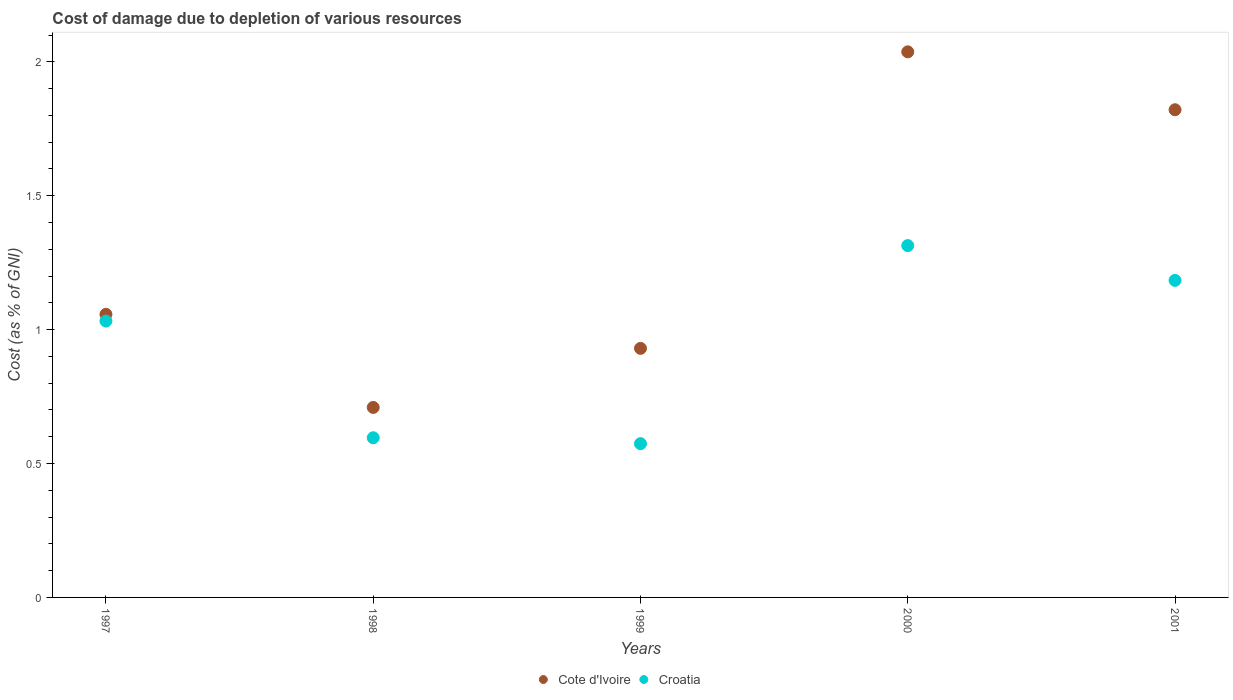Is the number of dotlines equal to the number of legend labels?
Your response must be concise. Yes. What is the cost of damage caused due to the depletion of various resources in Croatia in 2001?
Your answer should be compact. 1.18. Across all years, what is the maximum cost of damage caused due to the depletion of various resources in Croatia?
Your answer should be compact. 1.31. Across all years, what is the minimum cost of damage caused due to the depletion of various resources in Cote d'Ivoire?
Your response must be concise. 0.71. In which year was the cost of damage caused due to the depletion of various resources in Cote d'Ivoire maximum?
Provide a succinct answer. 2000. What is the total cost of damage caused due to the depletion of various resources in Croatia in the graph?
Provide a succinct answer. 4.7. What is the difference between the cost of damage caused due to the depletion of various resources in Cote d'Ivoire in 1999 and that in 2000?
Ensure brevity in your answer.  -1.11. What is the difference between the cost of damage caused due to the depletion of various resources in Cote d'Ivoire in 1998 and the cost of damage caused due to the depletion of various resources in Croatia in 1999?
Give a very brief answer. 0.14. What is the average cost of damage caused due to the depletion of various resources in Cote d'Ivoire per year?
Your answer should be compact. 1.31. In the year 2000, what is the difference between the cost of damage caused due to the depletion of various resources in Cote d'Ivoire and cost of damage caused due to the depletion of various resources in Croatia?
Offer a very short reply. 0.72. In how many years, is the cost of damage caused due to the depletion of various resources in Croatia greater than 1.4 %?
Offer a very short reply. 0. What is the ratio of the cost of damage caused due to the depletion of various resources in Croatia in 1997 to that in 2001?
Your response must be concise. 0.87. What is the difference between the highest and the second highest cost of damage caused due to the depletion of various resources in Cote d'Ivoire?
Your response must be concise. 0.22. What is the difference between the highest and the lowest cost of damage caused due to the depletion of various resources in Croatia?
Ensure brevity in your answer.  0.74. In how many years, is the cost of damage caused due to the depletion of various resources in Croatia greater than the average cost of damage caused due to the depletion of various resources in Croatia taken over all years?
Ensure brevity in your answer.  3. Is the cost of damage caused due to the depletion of various resources in Croatia strictly greater than the cost of damage caused due to the depletion of various resources in Cote d'Ivoire over the years?
Ensure brevity in your answer.  No. Is the cost of damage caused due to the depletion of various resources in Cote d'Ivoire strictly less than the cost of damage caused due to the depletion of various resources in Croatia over the years?
Make the answer very short. No. Does the graph contain any zero values?
Provide a short and direct response. No. How many legend labels are there?
Your response must be concise. 2. What is the title of the graph?
Keep it short and to the point. Cost of damage due to depletion of various resources. What is the label or title of the Y-axis?
Provide a succinct answer. Cost (as % of GNI). What is the Cost (as % of GNI) in Cote d'Ivoire in 1997?
Your response must be concise. 1.06. What is the Cost (as % of GNI) in Croatia in 1997?
Keep it short and to the point. 1.03. What is the Cost (as % of GNI) in Cote d'Ivoire in 1998?
Give a very brief answer. 0.71. What is the Cost (as % of GNI) in Croatia in 1998?
Give a very brief answer. 0.6. What is the Cost (as % of GNI) of Cote d'Ivoire in 1999?
Give a very brief answer. 0.93. What is the Cost (as % of GNI) in Croatia in 1999?
Provide a short and direct response. 0.57. What is the Cost (as % of GNI) of Cote d'Ivoire in 2000?
Make the answer very short. 2.04. What is the Cost (as % of GNI) of Croatia in 2000?
Your answer should be very brief. 1.31. What is the Cost (as % of GNI) of Cote d'Ivoire in 2001?
Provide a short and direct response. 1.82. What is the Cost (as % of GNI) of Croatia in 2001?
Give a very brief answer. 1.18. Across all years, what is the maximum Cost (as % of GNI) of Cote d'Ivoire?
Make the answer very short. 2.04. Across all years, what is the maximum Cost (as % of GNI) of Croatia?
Your answer should be compact. 1.31. Across all years, what is the minimum Cost (as % of GNI) in Cote d'Ivoire?
Provide a short and direct response. 0.71. Across all years, what is the minimum Cost (as % of GNI) of Croatia?
Keep it short and to the point. 0.57. What is the total Cost (as % of GNI) in Cote d'Ivoire in the graph?
Provide a short and direct response. 6.56. What is the total Cost (as % of GNI) in Croatia in the graph?
Your response must be concise. 4.7. What is the difference between the Cost (as % of GNI) in Cote d'Ivoire in 1997 and that in 1998?
Offer a very short reply. 0.35. What is the difference between the Cost (as % of GNI) of Croatia in 1997 and that in 1998?
Provide a succinct answer. 0.44. What is the difference between the Cost (as % of GNI) of Cote d'Ivoire in 1997 and that in 1999?
Your answer should be compact. 0.13. What is the difference between the Cost (as % of GNI) of Croatia in 1997 and that in 1999?
Your answer should be very brief. 0.46. What is the difference between the Cost (as % of GNI) of Cote d'Ivoire in 1997 and that in 2000?
Give a very brief answer. -0.98. What is the difference between the Cost (as % of GNI) of Croatia in 1997 and that in 2000?
Provide a short and direct response. -0.28. What is the difference between the Cost (as % of GNI) in Cote d'Ivoire in 1997 and that in 2001?
Offer a very short reply. -0.76. What is the difference between the Cost (as % of GNI) of Croatia in 1997 and that in 2001?
Keep it short and to the point. -0.15. What is the difference between the Cost (as % of GNI) in Cote d'Ivoire in 1998 and that in 1999?
Your answer should be very brief. -0.22. What is the difference between the Cost (as % of GNI) of Croatia in 1998 and that in 1999?
Give a very brief answer. 0.02. What is the difference between the Cost (as % of GNI) of Cote d'Ivoire in 1998 and that in 2000?
Offer a very short reply. -1.33. What is the difference between the Cost (as % of GNI) in Croatia in 1998 and that in 2000?
Give a very brief answer. -0.72. What is the difference between the Cost (as % of GNI) of Cote d'Ivoire in 1998 and that in 2001?
Give a very brief answer. -1.11. What is the difference between the Cost (as % of GNI) in Croatia in 1998 and that in 2001?
Provide a succinct answer. -0.59. What is the difference between the Cost (as % of GNI) of Cote d'Ivoire in 1999 and that in 2000?
Make the answer very short. -1.11. What is the difference between the Cost (as % of GNI) in Croatia in 1999 and that in 2000?
Provide a succinct answer. -0.74. What is the difference between the Cost (as % of GNI) of Cote d'Ivoire in 1999 and that in 2001?
Your response must be concise. -0.89. What is the difference between the Cost (as % of GNI) in Croatia in 1999 and that in 2001?
Offer a terse response. -0.61. What is the difference between the Cost (as % of GNI) in Cote d'Ivoire in 2000 and that in 2001?
Your answer should be compact. 0.22. What is the difference between the Cost (as % of GNI) of Croatia in 2000 and that in 2001?
Ensure brevity in your answer.  0.13. What is the difference between the Cost (as % of GNI) in Cote d'Ivoire in 1997 and the Cost (as % of GNI) in Croatia in 1998?
Ensure brevity in your answer.  0.46. What is the difference between the Cost (as % of GNI) in Cote d'Ivoire in 1997 and the Cost (as % of GNI) in Croatia in 1999?
Keep it short and to the point. 0.48. What is the difference between the Cost (as % of GNI) of Cote d'Ivoire in 1997 and the Cost (as % of GNI) of Croatia in 2000?
Ensure brevity in your answer.  -0.26. What is the difference between the Cost (as % of GNI) in Cote d'Ivoire in 1997 and the Cost (as % of GNI) in Croatia in 2001?
Your answer should be compact. -0.13. What is the difference between the Cost (as % of GNI) of Cote d'Ivoire in 1998 and the Cost (as % of GNI) of Croatia in 1999?
Make the answer very short. 0.14. What is the difference between the Cost (as % of GNI) of Cote d'Ivoire in 1998 and the Cost (as % of GNI) of Croatia in 2000?
Your answer should be compact. -0.6. What is the difference between the Cost (as % of GNI) of Cote d'Ivoire in 1998 and the Cost (as % of GNI) of Croatia in 2001?
Provide a succinct answer. -0.47. What is the difference between the Cost (as % of GNI) in Cote d'Ivoire in 1999 and the Cost (as % of GNI) in Croatia in 2000?
Make the answer very short. -0.38. What is the difference between the Cost (as % of GNI) of Cote d'Ivoire in 1999 and the Cost (as % of GNI) of Croatia in 2001?
Ensure brevity in your answer.  -0.25. What is the difference between the Cost (as % of GNI) of Cote d'Ivoire in 2000 and the Cost (as % of GNI) of Croatia in 2001?
Your answer should be compact. 0.85. What is the average Cost (as % of GNI) of Cote d'Ivoire per year?
Give a very brief answer. 1.31. What is the average Cost (as % of GNI) in Croatia per year?
Your answer should be compact. 0.94. In the year 1997, what is the difference between the Cost (as % of GNI) of Cote d'Ivoire and Cost (as % of GNI) of Croatia?
Your answer should be very brief. 0.03. In the year 1998, what is the difference between the Cost (as % of GNI) of Cote d'Ivoire and Cost (as % of GNI) of Croatia?
Provide a short and direct response. 0.11. In the year 1999, what is the difference between the Cost (as % of GNI) in Cote d'Ivoire and Cost (as % of GNI) in Croatia?
Provide a short and direct response. 0.36. In the year 2000, what is the difference between the Cost (as % of GNI) in Cote d'Ivoire and Cost (as % of GNI) in Croatia?
Ensure brevity in your answer.  0.72. In the year 2001, what is the difference between the Cost (as % of GNI) of Cote d'Ivoire and Cost (as % of GNI) of Croatia?
Provide a succinct answer. 0.64. What is the ratio of the Cost (as % of GNI) in Cote d'Ivoire in 1997 to that in 1998?
Offer a very short reply. 1.49. What is the ratio of the Cost (as % of GNI) in Croatia in 1997 to that in 1998?
Give a very brief answer. 1.73. What is the ratio of the Cost (as % of GNI) of Cote d'Ivoire in 1997 to that in 1999?
Make the answer very short. 1.14. What is the ratio of the Cost (as % of GNI) in Croatia in 1997 to that in 1999?
Your answer should be very brief. 1.8. What is the ratio of the Cost (as % of GNI) of Cote d'Ivoire in 1997 to that in 2000?
Offer a very short reply. 0.52. What is the ratio of the Cost (as % of GNI) in Croatia in 1997 to that in 2000?
Keep it short and to the point. 0.79. What is the ratio of the Cost (as % of GNI) of Cote d'Ivoire in 1997 to that in 2001?
Your response must be concise. 0.58. What is the ratio of the Cost (as % of GNI) of Croatia in 1997 to that in 2001?
Your answer should be very brief. 0.87. What is the ratio of the Cost (as % of GNI) in Cote d'Ivoire in 1998 to that in 1999?
Keep it short and to the point. 0.76. What is the ratio of the Cost (as % of GNI) in Croatia in 1998 to that in 1999?
Your response must be concise. 1.04. What is the ratio of the Cost (as % of GNI) in Cote d'Ivoire in 1998 to that in 2000?
Provide a short and direct response. 0.35. What is the ratio of the Cost (as % of GNI) of Croatia in 1998 to that in 2000?
Provide a succinct answer. 0.45. What is the ratio of the Cost (as % of GNI) of Cote d'Ivoire in 1998 to that in 2001?
Give a very brief answer. 0.39. What is the ratio of the Cost (as % of GNI) of Croatia in 1998 to that in 2001?
Provide a short and direct response. 0.5. What is the ratio of the Cost (as % of GNI) of Cote d'Ivoire in 1999 to that in 2000?
Provide a short and direct response. 0.46. What is the ratio of the Cost (as % of GNI) in Croatia in 1999 to that in 2000?
Offer a very short reply. 0.44. What is the ratio of the Cost (as % of GNI) of Cote d'Ivoire in 1999 to that in 2001?
Keep it short and to the point. 0.51. What is the ratio of the Cost (as % of GNI) of Croatia in 1999 to that in 2001?
Offer a terse response. 0.48. What is the ratio of the Cost (as % of GNI) of Cote d'Ivoire in 2000 to that in 2001?
Offer a terse response. 1.12. What is the ratio of the Cost (as % of GNI) in Croatia in 2000 to that in 2001?
Ensure brevity in your answer.  1.11. What is the difference between the highest and the second highest Cost (as % of GNI) of Cote d'Ivoire?
Keep it short and to the point. 0.22. What is the difference between the highest and the second highest Cost (as % of GNI) of Croatia?
Your answer should be compact. 0.13. What is the difference between the highest and the lowest Cost (as % of GNI) in Cote d'Ivoire?
Make the answer very short. 1.33. What is the difference between the highest and the lowest Cost (as % of GNI) of Croatia?
Offer a terse response. 0.74. 